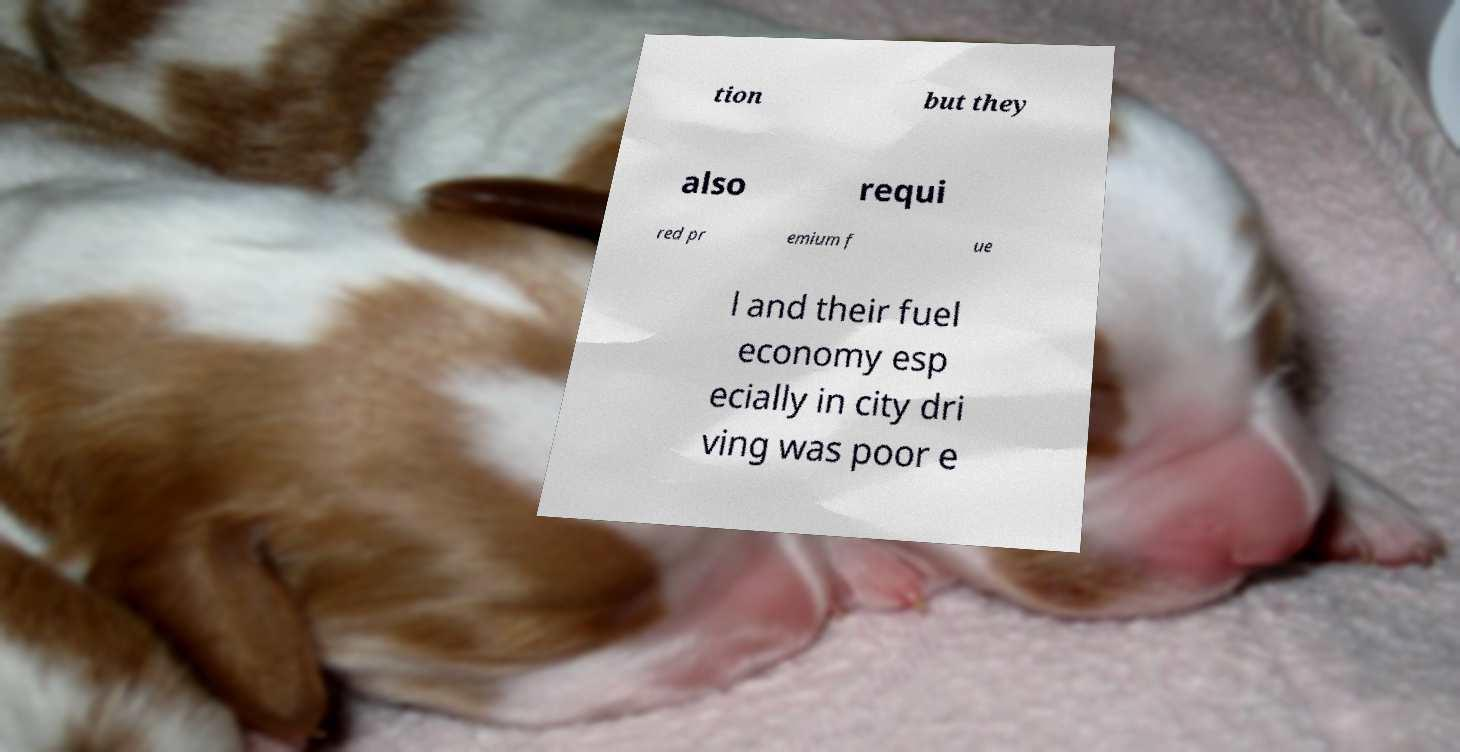Could you extract and type out the text from this image? tion but they also requi red pr emium f ue l and their fuel economy esp ecially in city dri ving was poor e 